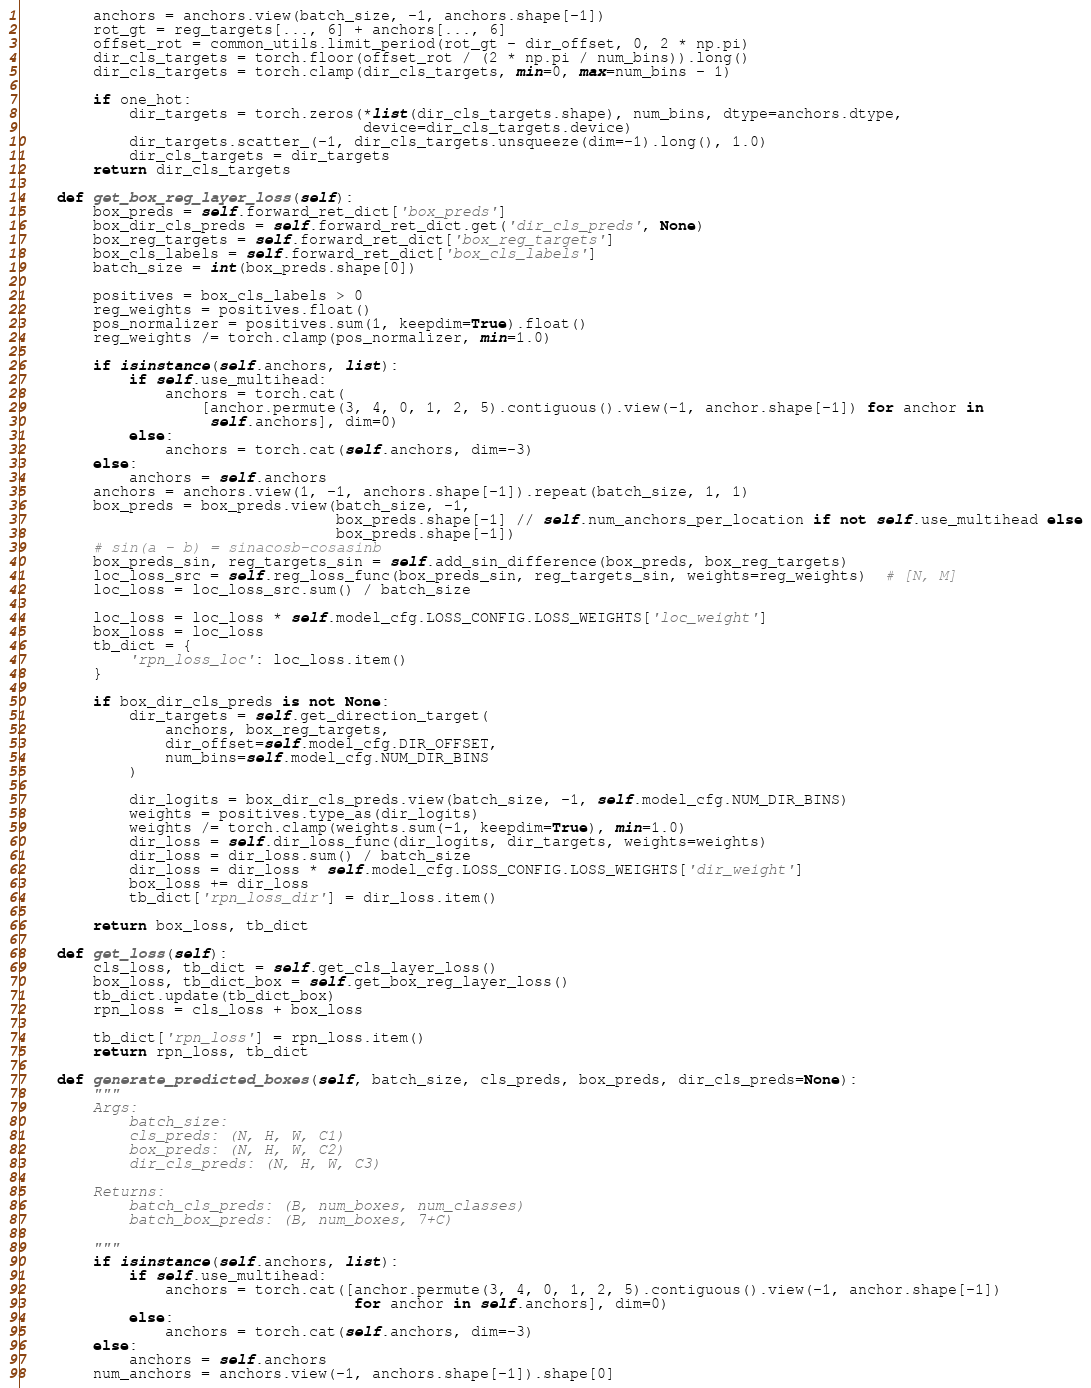<code> <loc_0><loc_0><loc_500><loc_500><_Python_>        anchors = anchors.view(batch_size, -1, anchors.shape[-1])
        rot_gt = reg_targets[..., 6] + anchors[..., 6]
        offset_rot = common_utils.limit_period(rot_gt - dir_offset, 0, 2 * np.pi)
        dir_cls_targets = torch.floor(offset_rot / (2 * np.pi / num_bins)).long()
        dir_cls_targets = torch.clamp(dir_cls_targets, min=0, max=num_bins - 1)

        if one_hot:
            dir_targets = torch.zeros(*list(dir_cls_targets.shape), num_bins, dtype=anchors.dtype,
                                      device=dir_cls_targets.device)
            dir_targets.scatter_(-1, dir_cls_targets.unsqueeze(dim=-1).long(), 1.0)
            dir_cls_targets = dir_targets
        return dir_cls_targets

    def get_box_reg_layer_loss(self):
        box_preds = self.forward_ret_dict['box_preds']
        box_dir_cls_preds = self.forward_ret_dict.get('dir_cls_preds', None)
        box_reg_targets = self.forward_ret_dict['box_reg_targets']
        box_cls_labels = self.forward_ret_dict['box_cls_labels']
        batch_size = int(box_preds.shape[0])

        positives = box_cls_labels > 0
        reg_weights = positives.float()
        pos_normalizer = positives.sum(1, keepdim=True).float()
        reg_weights /= torch.clamp(pos_normalizer, min=1.0)

        if isinstance(self.anchors, list):
            if self.use_multihead:
                anchors = torch.cat(
                    [anchor.permute(3, 4, 0, 1, 2, 5).contiguous().view(-1, anchor.shape[-1]) for anchor in
                     self.anchors], dim=0)
            else:
                anchors = torch.cat(self.anchors, dim=-3)
        else:
            anchors = self.anchors
        anchors = anchors.view(1, -1, anchors.shape[-1]).repeat(batch_size, 1, 1)
        box_preds = box_preds.view(batch_size, -1,
                                   box_preds.shape[-1] // self.num_anchors_per_location if not self.use_multihead else
                                   box_preds.shape[-1])
        # sin(a - b) = sinacosb-cosasinb
        box_preds_sin, reg_targets_sin = self.add_sin_difference(box_preds, box_reg_targets)
        loc_loss_src = self.reg_loss_func(box_preds_sin, reg_targets_sin, weights=reg_weights)  # [N, M]
        loc_loss = loc_loss_src.sum() / batch_size

        loc_loss = loc_loss * self.model_cfg.LOSS_CONFIG.LOSS_WEIGHTS['loc_weight']
        box_loss = loc_loss
        tb_dict = {
            'rpn_loss_loc': loc_loss.item()
        }

        if box_dir_cls_preds is not None:
            dir_targets = self.get_direction_target(
                anchors, box_reg_targets,
                dir_offset=self.model_cfg.DIR_OFFSET,
                num_bins=self.model_cfg.NUM_DIR_BINS
            )

            dir_logits = box_dir_cls_preds.view(batch_size, -1, self.model_cfg.NUM_DIR_BINS)
            weights = positives.type_as(dir_logits)
            weights /= torch.clamp(weights.sum(-1, keepdim=True), min=1.0)
            dir_loss = self.dir_loss_func(dir_logits, dir_targets, weights=weights)
            dir_loss = dir_loss.sum() / batch_size
            dir_loss = dir_loss * self.model_cfg.LOSS_CONFIG.LOSS_WEIGHTS['dir_weight']
            box_loss += dir_loss
            tb_dict['rpn_loss_dir'] = dir_loss.item()

        return box_loss, tb_dict

    def get_loss(self):
        cls_loss, tb_dict = self.get_cls_layer_loss()
        box_loss, tb_dict_box = self.get_box_reg_layer_loss()
        tb_dict.update(tb_dict_box)
        rpn_loss = cls_loss + box_loss

        tb_dict['rpn_loss'] = rpn_loss.item()
        return rpn_loss, tb_dict

    def generate_predicted_boxes(self, batch_size, cls_preds, box_preds, dir_cls_preds=None):
        """
        Args:
            batch_size:
            cls_preds: (N, H, W, C1)
            box_preds: (N, H, W, C2)
            dir_cls_preds: (N, H, W, C3)

        Returns:
            batch_cls_preds: (B, num_boxes, num_classes)
            batch_box_preds: (B, num_boxes, 7+C)

        """
        if isinstance(self.anchors, list):
            if self.use_multihead:
                anchors = torch.cat([anchor.permute(3, 4, 0, 1, 2, 5).contiguous().view(-1, anchor.shape[-1])
                                     for anchor in self.anchors], dim=0)
            else:
                anchors = torch.cat(self.anchors, dim=-3)
        else:
            anchors = self.anchors
        num_anchors = anchors.view(-1, anchors.shape[-1]).shape[0]</code> 